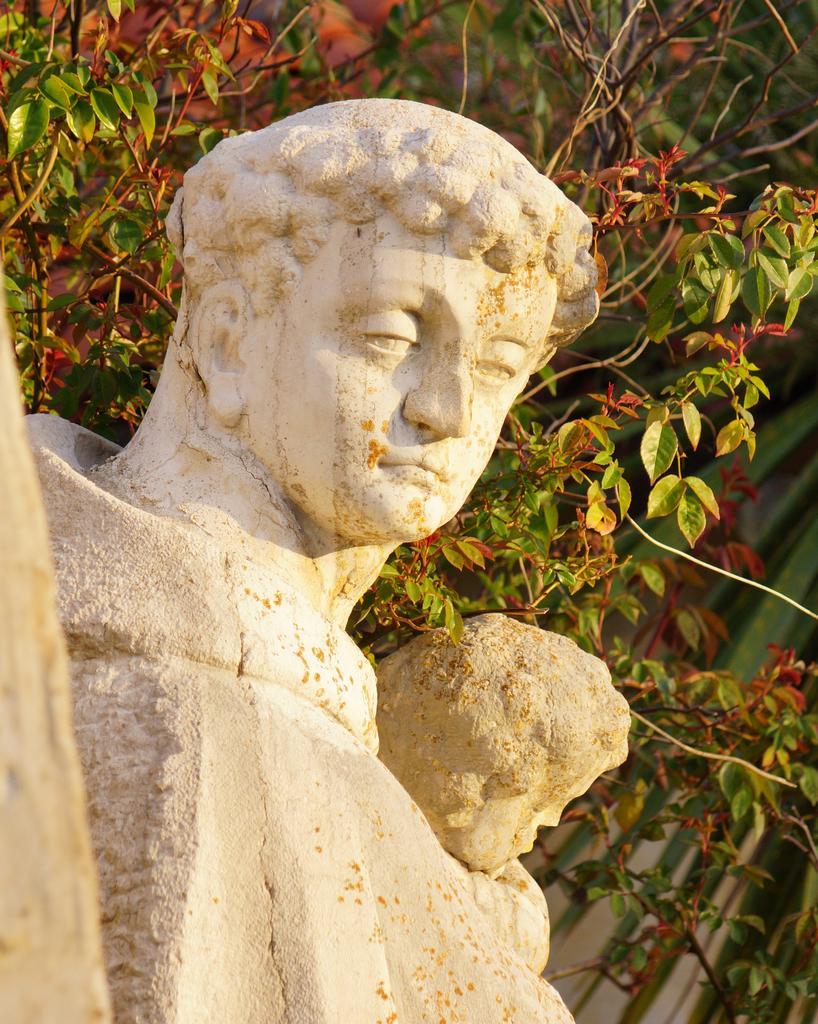Describe this image in one or two sentences. In this image, we can see some statues and we can see some trees. 